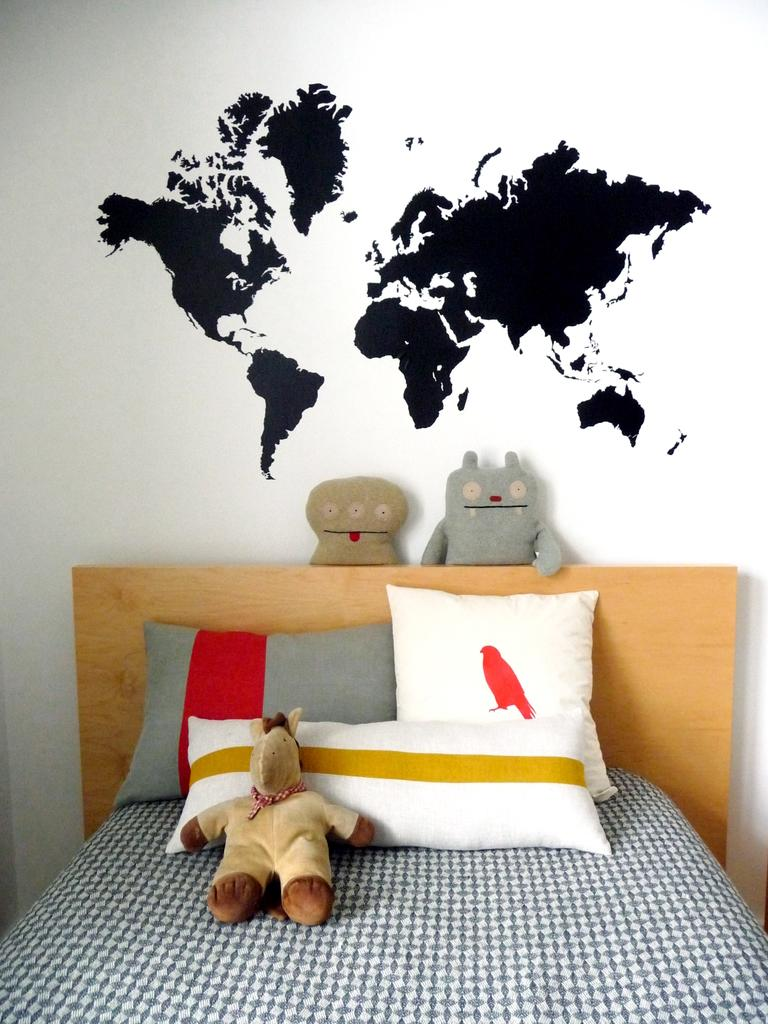What type of furniture is present in the image? There is a bed in the image. How are the pillows arranged on the bed? Pillows are arranged on the bed. What else can be seen in the image besides the bed and pillows? Toys are arranged in the image. What is the main subject of the painting in the image? There is a painting of a map at the center of the image on the wall. How many snails are crawling on the bed in the image? There are no snails present in the image; the bed is only adorned with pillows. 